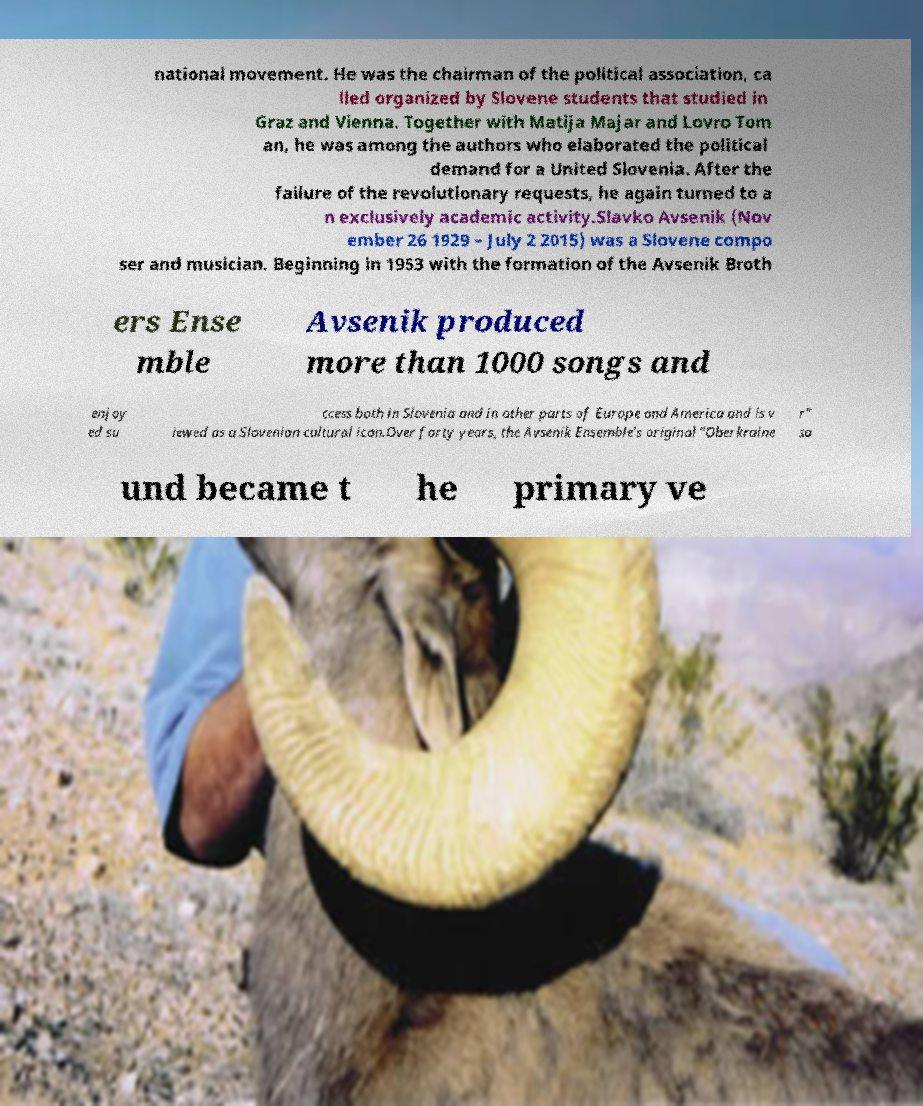Can you read and provide the text displayed in the image?This photo seems to have some interesting text. Can you extract and type it out for me? national movement. He was the chairman of the political association, ca lled organized by Slovene students that studied in Graz and Vienna. Together with Matija Majar and Lovro Tom an, he was among the authors who elaborated the political demand for a United Slovenia. After the failure of the revolutionary requests, he again turned to a n exclusively academic activity.Slavko Avsenik (Nov ember 26 1929 – July 2 2015) was a Slovene compo ser and musician. Beginning in 1953 with the formation of the Avsenik Broth ers Ense mble Avsenik produced more than 1000 songs and enjoy ed su ccess both in Slovenia and in other parts of Europe and America and is v iewed as a Slovenian cultural icon.Over forty years, the Avsenik Ensemble's original "Oberkraine r" so und became t he primary ve 